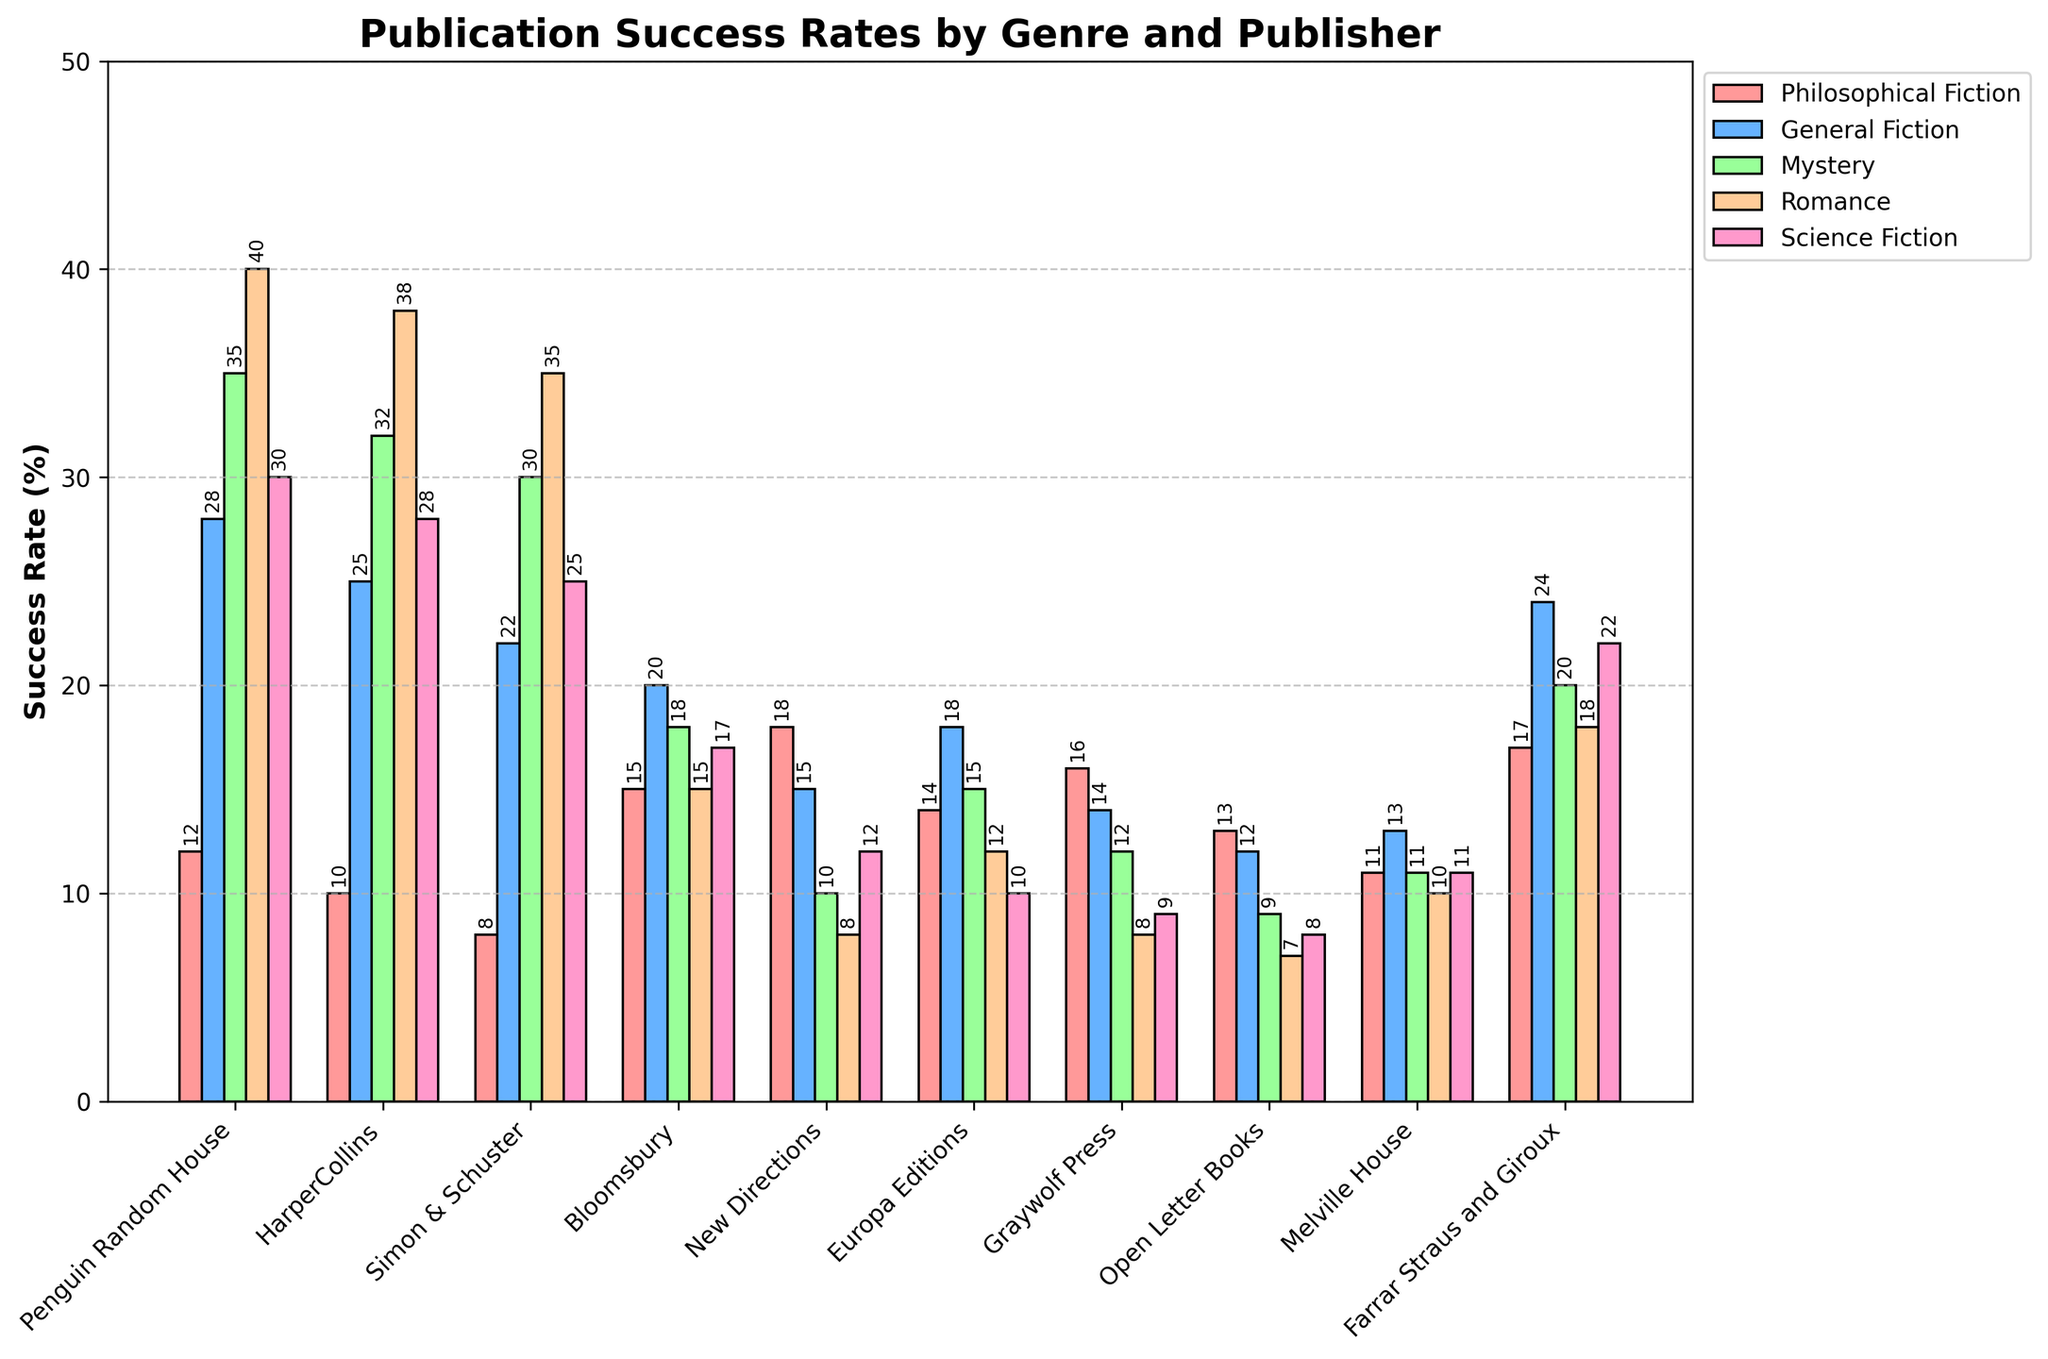What is the publisher with the highest success rate for Philosophical Fiction? To find the publisher with the highest success rate for Philosophical Fiction, look at the height of the bars corresponding to Philosophical Fiction. The highest bar belongs to New Directions.
Answer: New Directions Which genre has the highest overall success rate across all publishers? To determine the genre with the highest overall success rate, observe the heights of the bars for each genre across all publishers. Mystery and Romance have the highest bars but Romance is slightly higher in more publishers.
Answer: Romance How does the success rate of Philosophical Fiction compare to General Fiction for Penguin Random House? Look at the bars for Penguin Random House. The bar for General Fiction is taller than the bar for Philosophical Fiction. The success rate for Philosophical Fiction is 12%, and for General Fiction, it is 28%.
Answer: General Fiction is higher What is the success rate difference between Mystery and Science Fiction for Simon & Schuster? Identify the bars for Mystery and Science Fiction for Simon & Schuster. Mystery has a success rate of 30%, and Science Fiction has a success rate of 25%.
Answer: 5% Which publisher has the most balanced success rates across different genres? To find the most balanced success rate, observe the bars that have similar heights for a publisher across all genres. Bloomsbury shows relatively similar heights, with success rates ranging from 15% to 20%.
Answer: Bloomsbury Which genre has the lowest success rate for Bloomsbury? Look at the bars for Bloomsbury and identify the shortest one. The shortest bar belongs to Romance with a success rate of 15%.
Answer: Romance For which publishers is the success rate of Philosophical Fiction higher than Science Fiction? First, identify the bars for Philosophical Fiction and Science Fiction for each publisher. Compare their heights. The relevant publishers are Bloomsbury, New Directions, Europa Editions, Graywolf Press, Open Letter Books.
Answer: Bloomsbury, New Directions, Europa Editions, Graywolf Press, Open Letter Books Calculate the average success rate of Romance across all publishers. Sum the success rates of Romance for all publishers and divide by the number of publishers: (40+38+35+15+8+12+8+7+10+18)/10 = 191/10 = 19.1.
Answer: 19.1% Which publisher has the widest range between its highest and lowest success rate across genres? Calculate the difference between the highest and lowest success rates for each publisher. New Directions has the widest range, from 18% to 8%, which gives a range of 10%.
Answer: New Directions What's the total success rate across all genres for Farrar Straus and Giroux? Sum the success rates for all genres for Farrar Straus and Giroux: 17 (Philosophical Fiction) + 24 (General Fiction) + 20 (Mystery) + 18 (Romance) + 22 (Science Fiction) = 101.
Answer: 101 